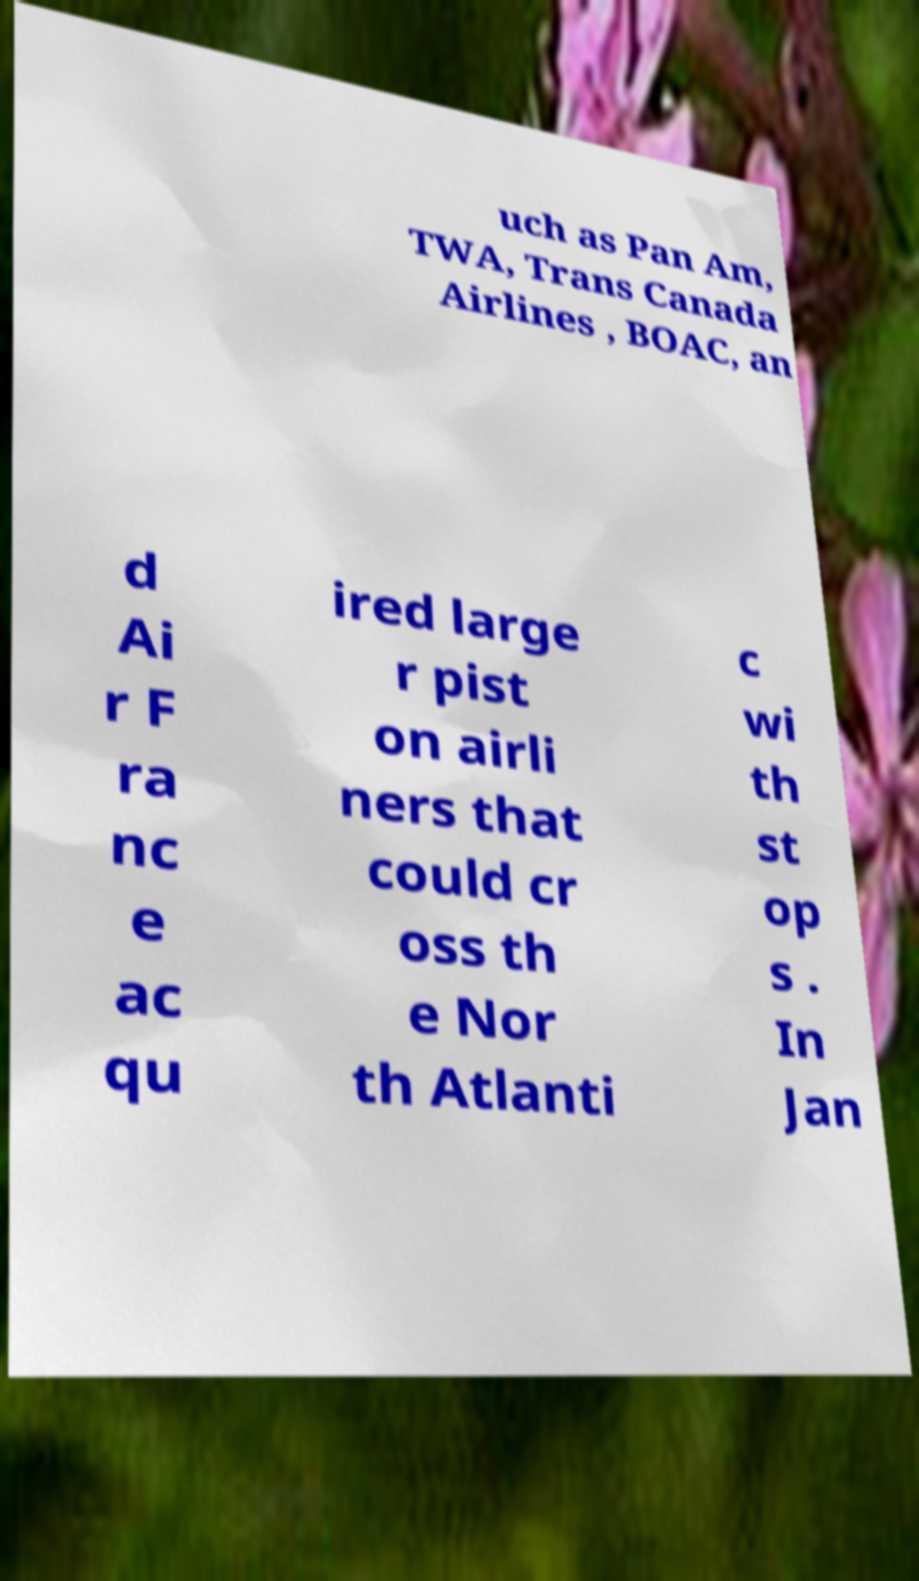Could you extract and type out the text from this image? uch as Pan Am, TWA, Trans Canada Airlines , BOAC, an d Ai r F ra nc e ac qu ired large r pist on airli ners that could cr oss th e Nor th Atlanti c wi th st op s . In Jan 